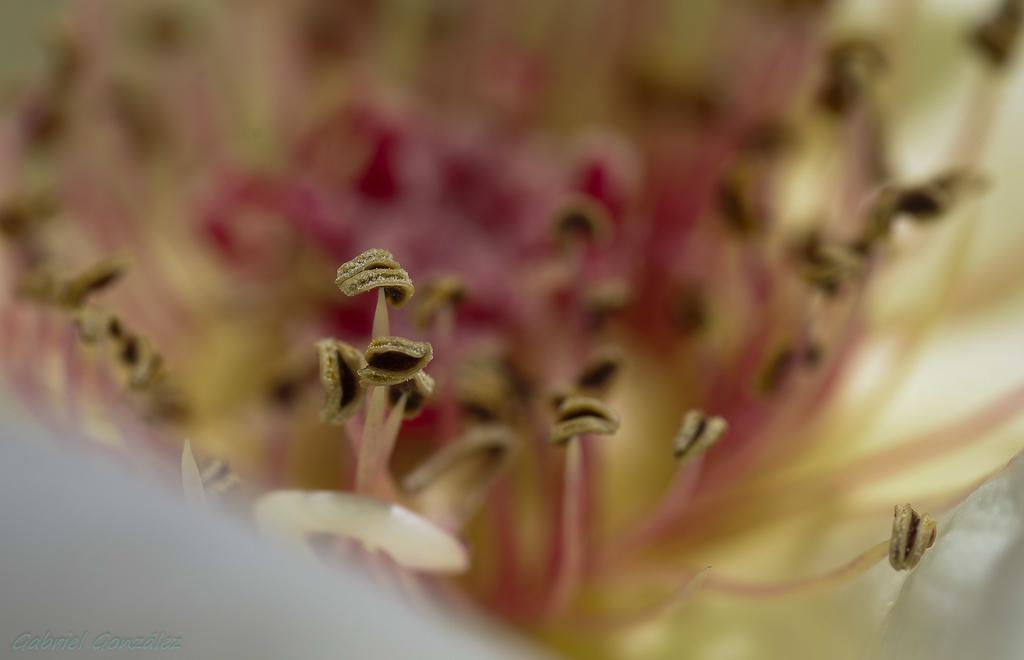What type of plant parts are visible in the image? There are flower parts in the image. Can you describe the appearance of the flower parts? The flower parts resemble stamens. How would you describe the overall clarity of the image? The image is blurred. Where is the cushion placed in the image? There is no cushion present in the image. What type of animal can be seen interacting with the brick in the image? There is no brick or animal present in the image. 